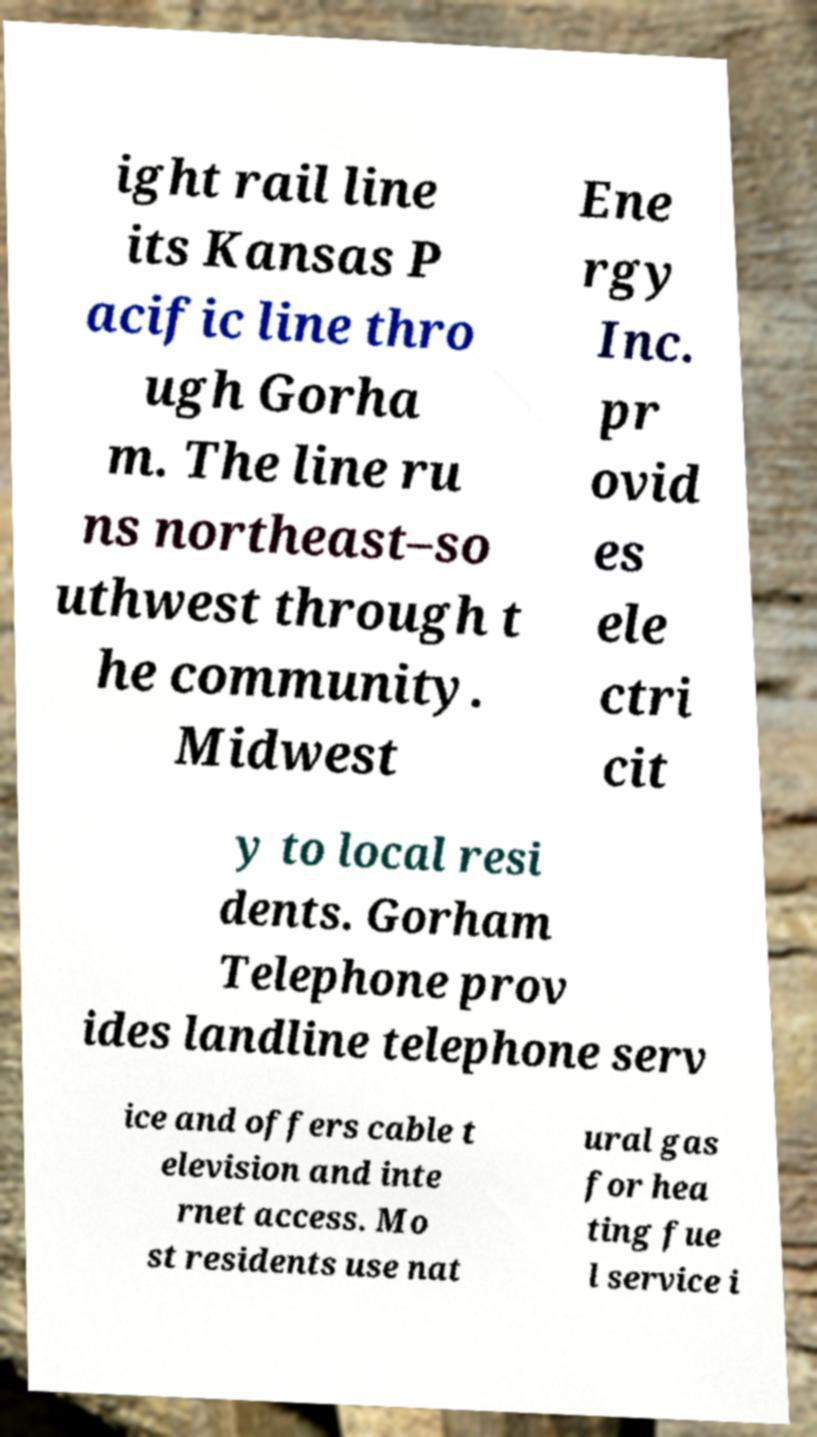What messages or text are displayed in this image? I need them in a readable, typed format. ight rail line its Kansas P acific line thro ugh Gorha m. The line ru ns northeast–so uthwest through t he community. Midwest Ene rgy Inc. pr ovid es ele ctri cit y to local resi dents. Gorham Telephone prov ides landline telephone serv ice and offers cable t elevision and inte rnet access. Mo st residents use nat ural gas for hea ting fue l service i 